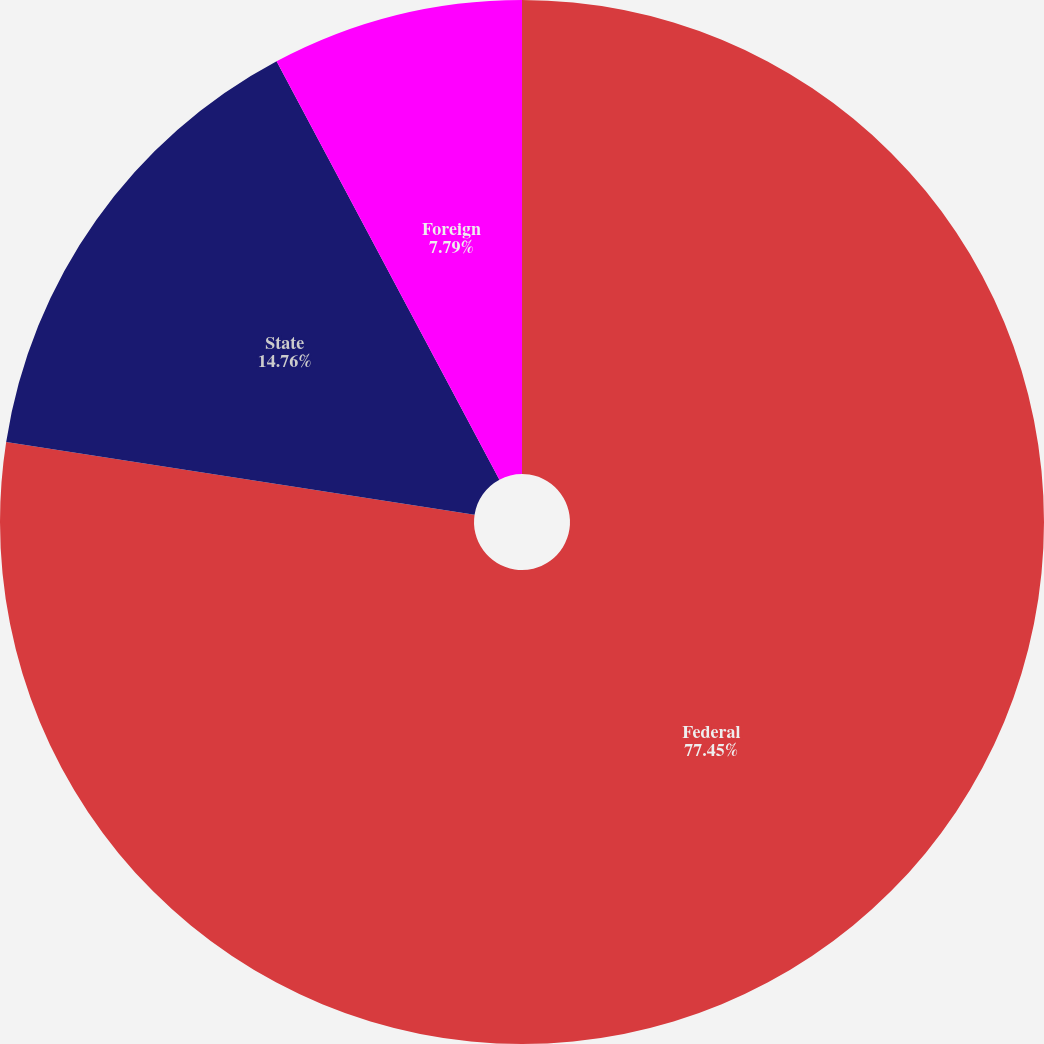Convert chart. <chart><loc_0><loc_0><loc_500><loc_500><pie_chart><fcel>Federal<fcel>State<fcel>Foreign<nl><fcel>77.45%<fcel>14.76%<fcel>7.79%<nl></chart> 